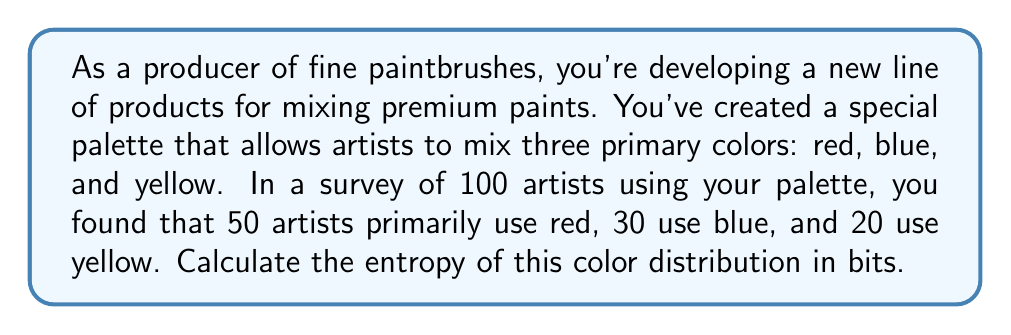Help me with this question. To calculate the entropy of the color distribution, we'll use the formula for Shannon entropy:

$$H = -\sum_{i=1}^{n} p_i \log_2(p_i)$$

Where:
- $H$ is the entropy in bits
- $p_i$ is the probability of each event (in this case, the probability of using each color)
- $n$ is the number of possible events (in this case, 3 colors)

Step 1: Calculate the probabilities for each color
- Red: $p_1 = 50/100 = 0.5$
- Blue: $p_2 = 30/100 = 0.3$
- Yellow: $p_3 = 20/100 = 0.2$

Step 2: Calculate each term in the sum
- For Red: $-0.5 \log_2(0.5) = 0.5$
- For Blue: $-0.3 \log_2(0.3) \approx 0.5211$
- For Yellow: $-0.2 \log_2(0.2) \approx 0.4644$

Step 3: Sum all terms
$$H = 0.5 + 0.5211 + 0.4644 = 1.4855$$

Therefore, the entropy of the color distribution is approximately 1.4855 bits.
Answer: 1.4855 bits 